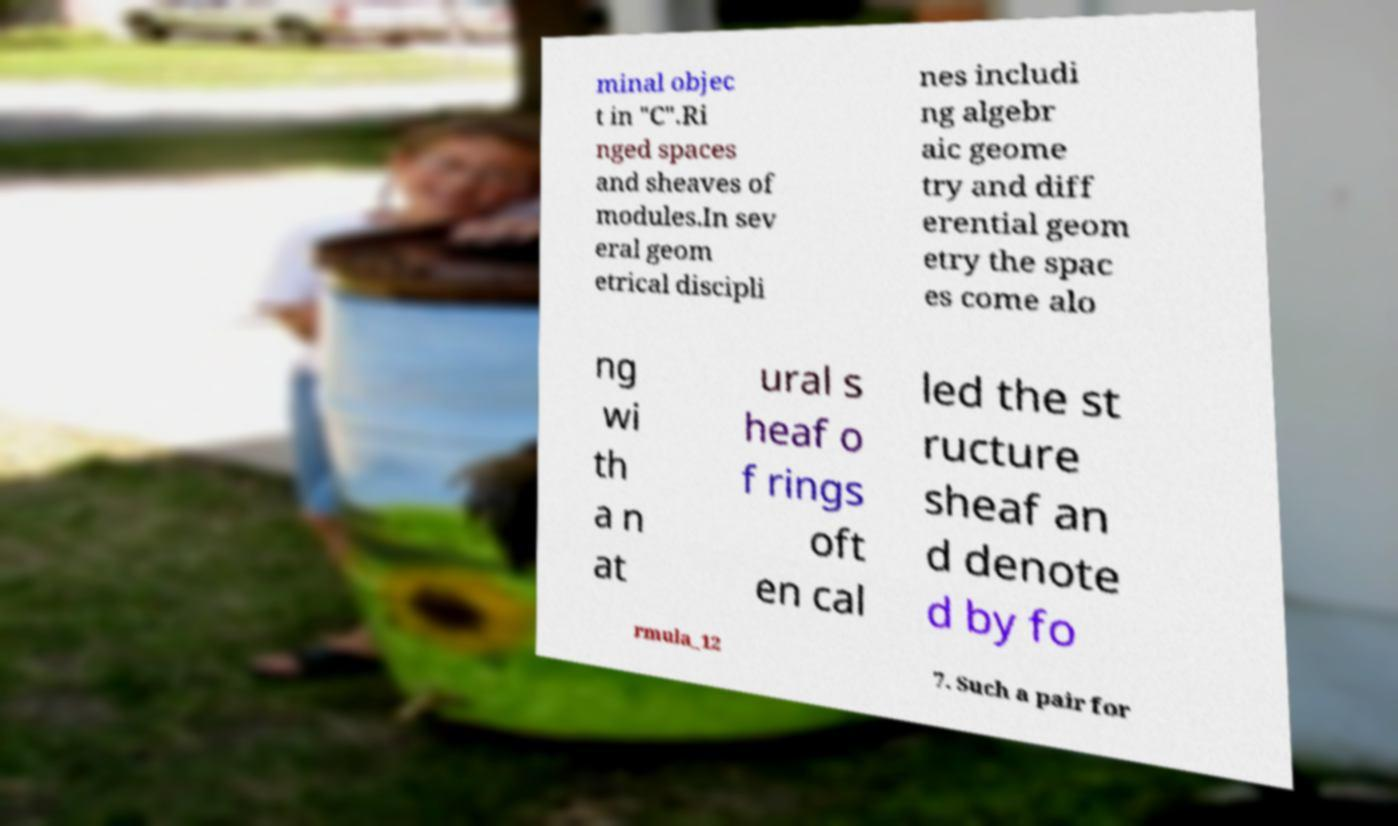Could you assist in decoding the text presented in this image and type it out clearly? minal objec t in "C".Ri nged spaces and sheaves of modules.In sev eral geom etrical discipli nes includi ng algebr aic geome try and diff erential geom etry the spac es come alo ng wi th a n at ural s heaf o f rings oft en cal led the st ructure sheaf an d denote d by fo rmula_12 7. Such a pair for 